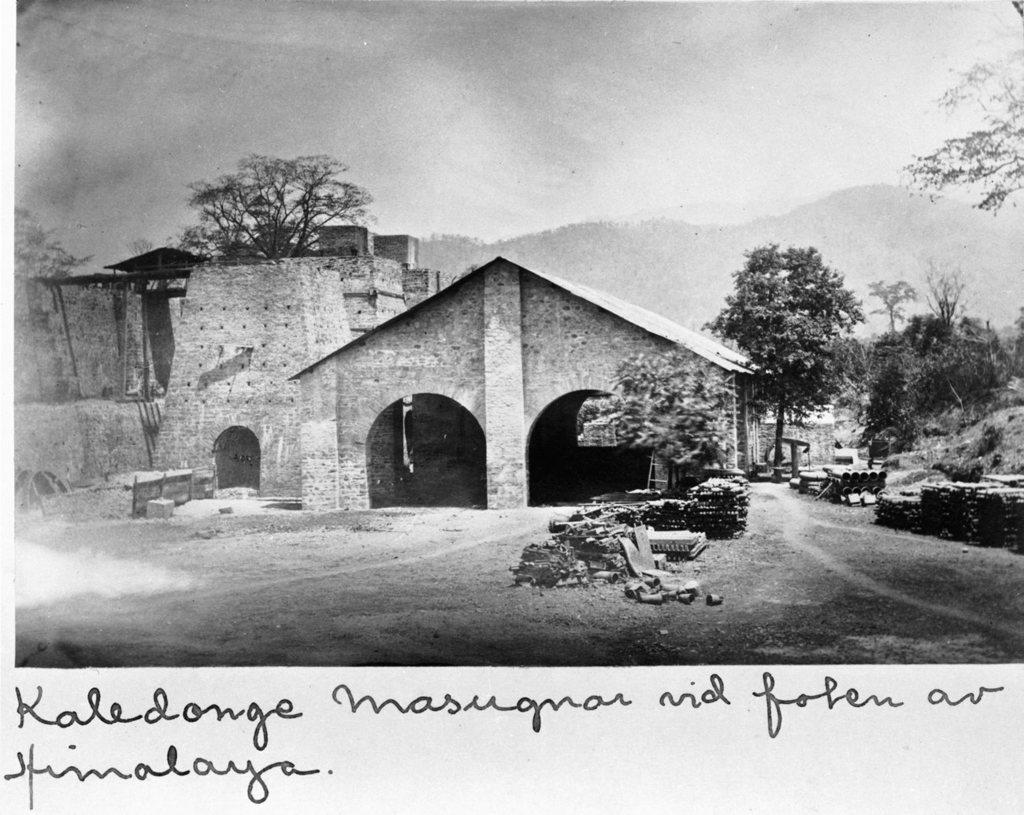What is the color scheme of the image? The image is black and white. What type of structure can be seen in the image? There is a shed in the image. What other structures are present in the image? There are buildings in the image. What natural elements can be seen in the image? There are trees and a mountain in the image. What man-made elements can be seen in the image? There are pipes and bricks in the image. What is visible in the background of the image? The sky is visible in the image. Is there any text associated with the image? Yes, there is text written below the image. What type of instrument is being played by the jellyfish in the image? There are no jellyfish or instruments present in the image. 